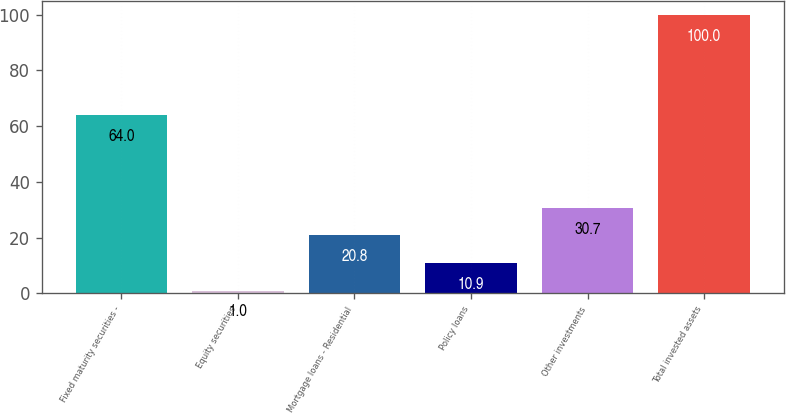<chart> <loc_0><loc_0><loc_500><loc_500><bar_chart><fcel>Fixed maturity securities -<fcel>Equity securities<fcel>Mortgage loans - Residential<fcel>Policy loans<fcel>Other investments<fcel>Total invested assets<nl><fcel>64<fcel>1<fcel>20.8<fcel>10.9<fcel>30.7<fcel>100<nl></chart> 